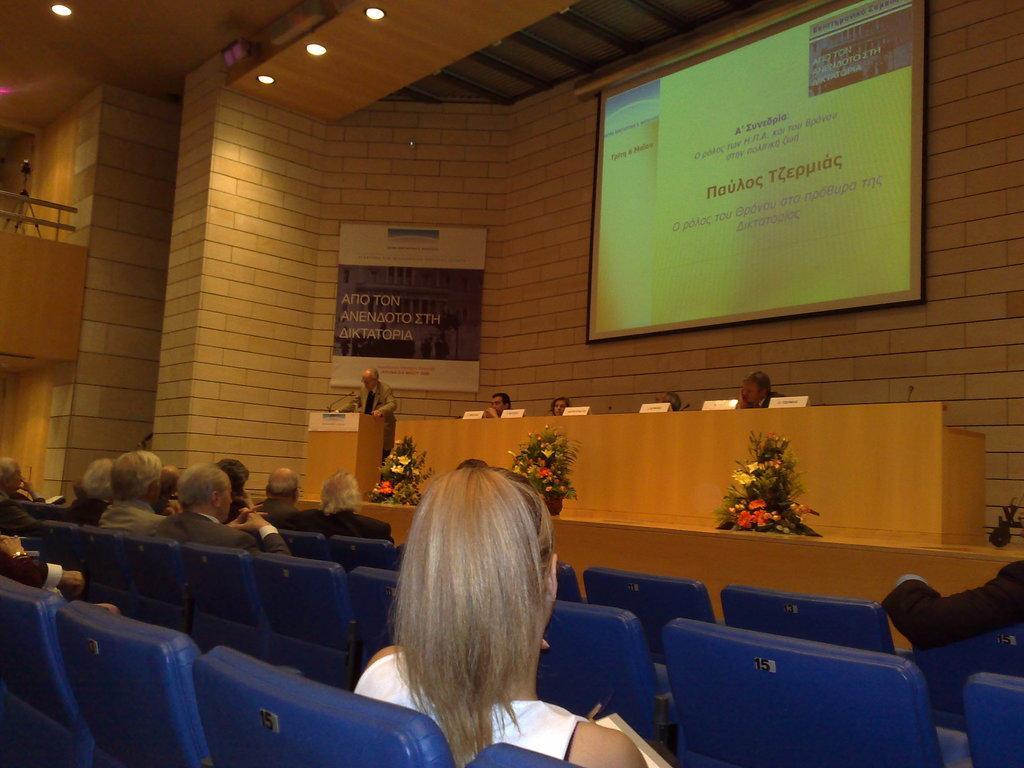In one or two sentences, can you explain what this image depicts? On the left side, there are persons in different color dresses sitting on the blue color chairs which are arranged on a floor. In the background, there are persons sitting in front of a table, on which there are name boards arranged, beside them, there is a person standing in front of a stand, there is a banner attached to the wall, there is a screen and there are lights attached to the roof. 